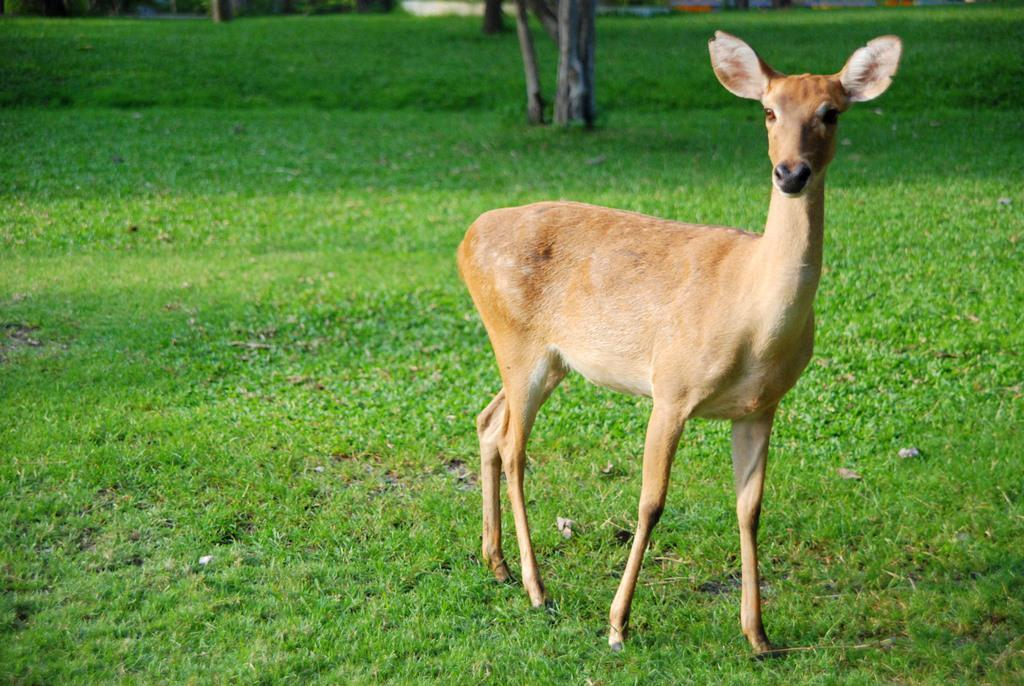What animal is present in the image? There is a deer in the image. What is the deer standing on? The deer is on the grass. What can be seen in the background of the image? There are tree trunks visible in the background of the image. What type of calculator is the deer using in the image? There is no calculator present in the image; it features a deer standing on the grass with tree trunks visible in the background. 